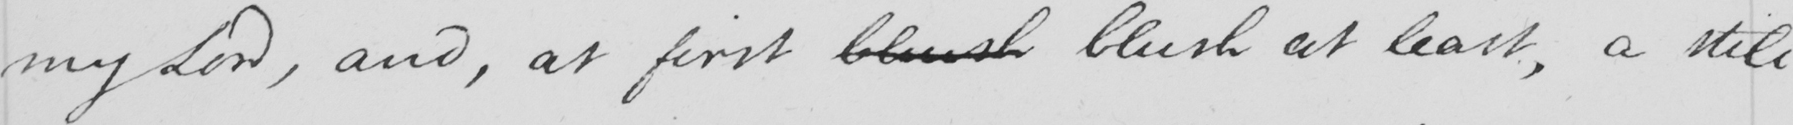What does this handwritten line say? my Lord , and , at first blush blush at least , a still 